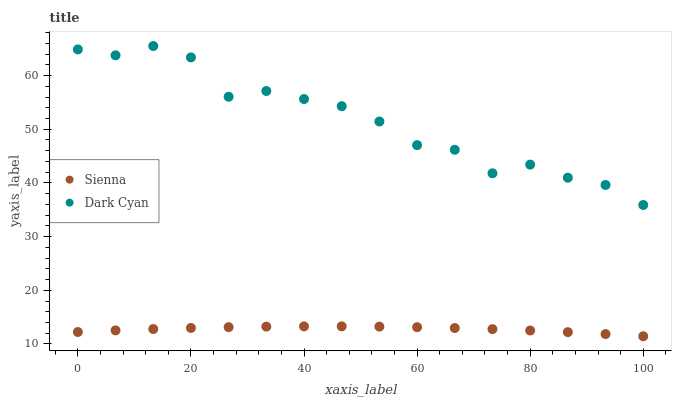Does Sienna have the minimum area under the curve?
Answer yes or no. Yes. Does Dark Cyan have the maximum area under the curve?
Answer yes or no. Yes. Does Dark Cyan have the minimum area under the curve?
Answer yes or no. No. Is Sienna the smoothest?
Answer yes or no. Yes. Is Dark Cyan the roughest?
Answer yes or no. Yes. Is Dark Cyan the smoothest?
Answer yes or no. No. Does Sienna have the lowest value?
Answer yes or no. Yes. Does Dark Cyan have the lowest value?
Answer yes or no. No. Does Dark Cyan have the highest value?
Answer yes or no. Yes. Is Sienna less than Dark Cyan?
Answer yes or no. Yes. Is Dark Cyan greater than Sienna?
Answer yes or no. Yes. Does Sienna intersect Dark Cyan?
Answer yes or no. No. 